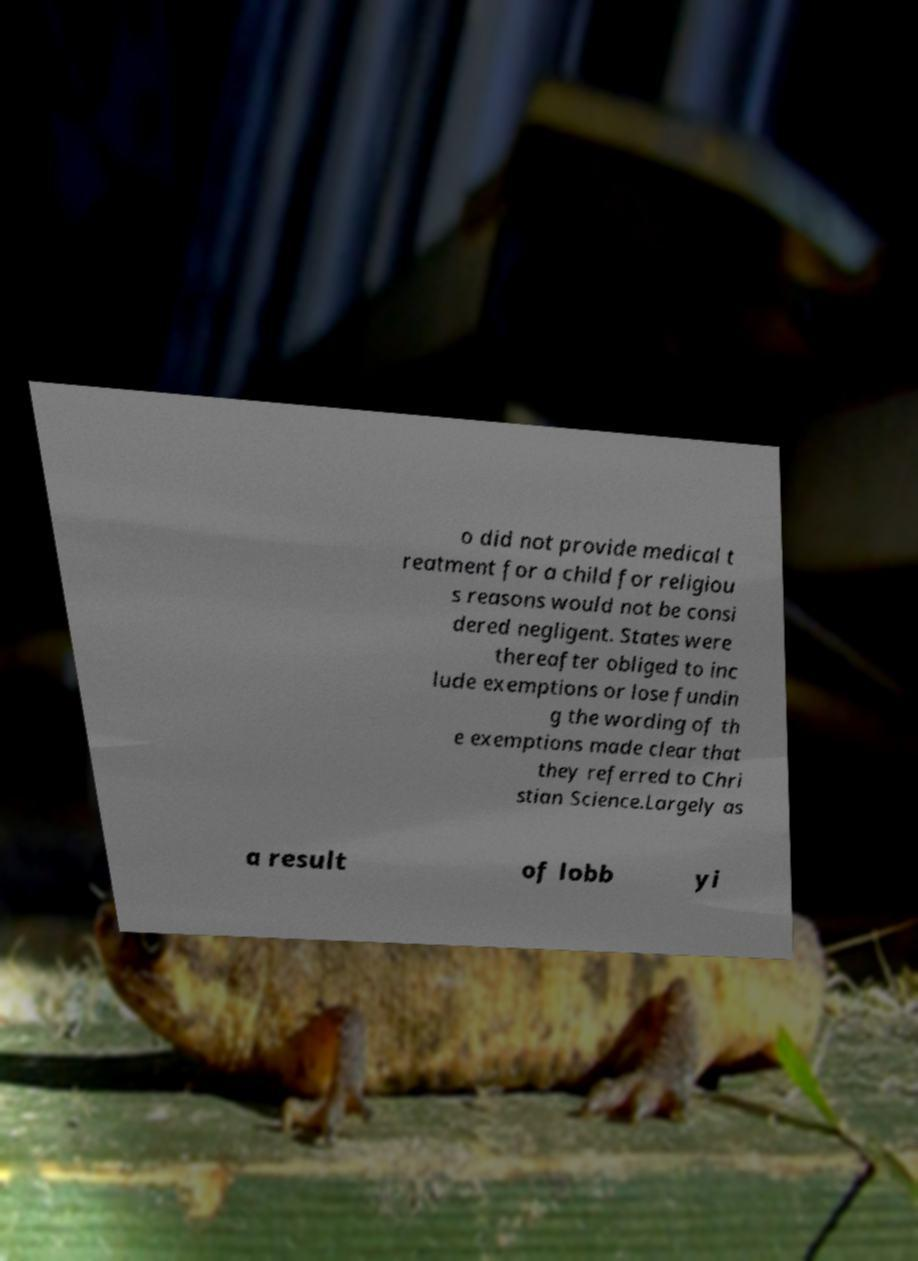Could you extract and type out the text from this image? o did not provide medical t reatment for a child for religiou s reasons would not be consi dered negligent. States were thereafter obliged to inc lude exemptions or lose fundin g the wording of th e exemptions made clear that they referred to Chri stian Science.Largely as a result of lobb yi 